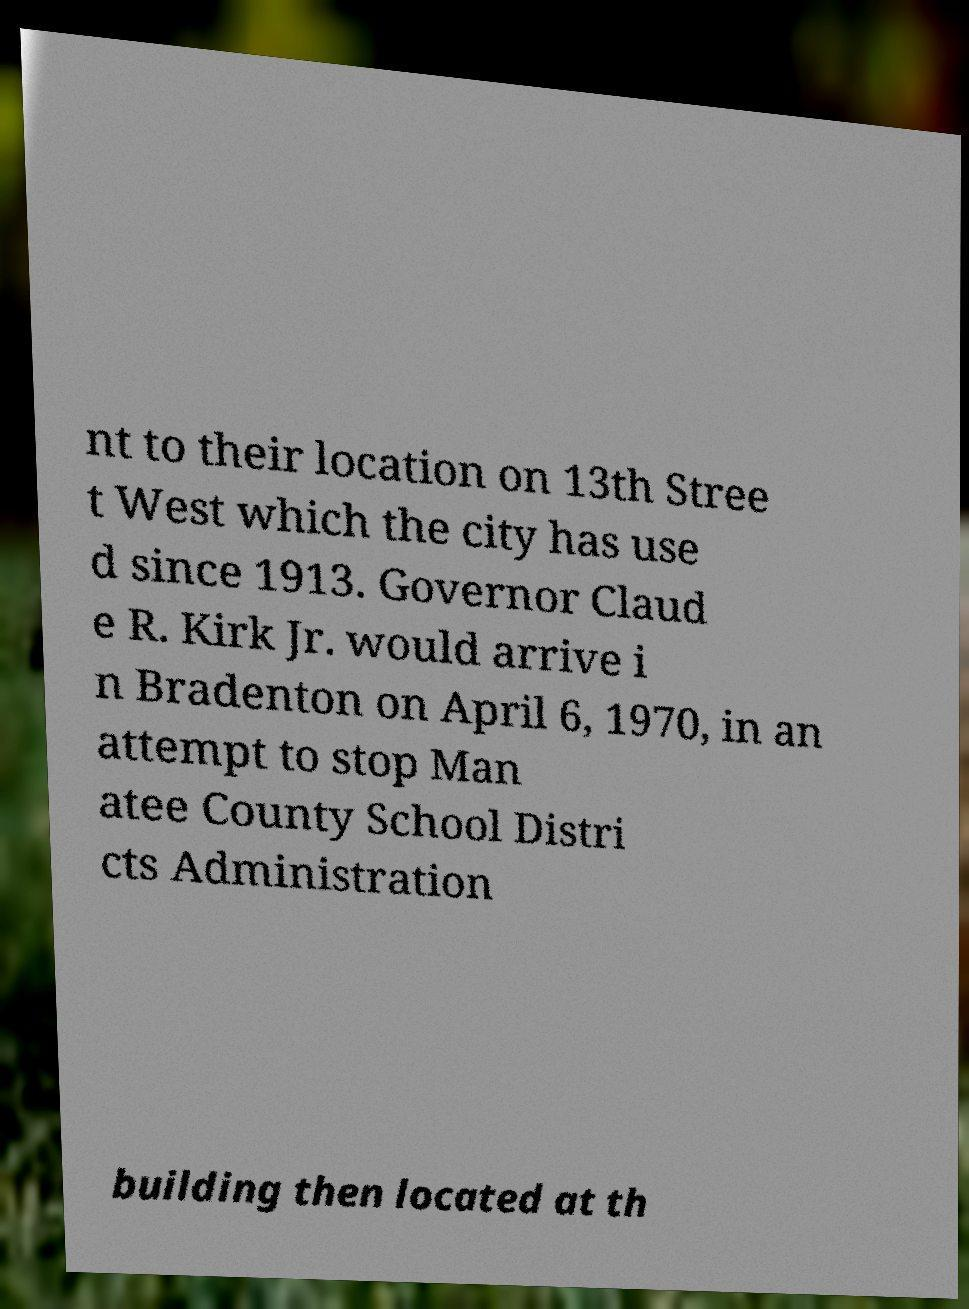There's text embedded in this image that I need extracted. Can you transcribe it verbatim? nt to their location on 13th Stree t West which the city has use d since 1913. Governor Claud e R. Kirk Jr. would arrive i n Bradenton on April 6, 1970, in an attempt to stop Man atee County School Distri cts Administration building then located at th 